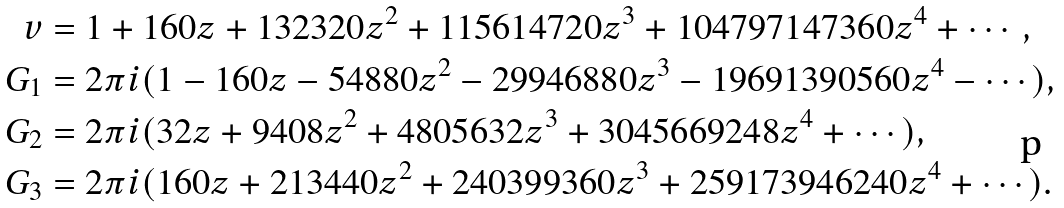Convert formula to latex. <formula><loc_0><loc_0><loc_500><loc_500>v & = 1 + 1 6 0 z + 1 3 2 3 2 0 z ^ { 2 } + 1 1 5 6 1 4 7 2 0 z ^ { 3 } + 1 0 4 7 9 7 1 4 7 3 6 0 z ^ { 4 } + \cdots , \\ G _ { 1 } & = 2 \pi i ( 1 - 1 6 0 z - 5 4 8 8 0 z ^ { 2 } - 2 9 9 4 6 8 8 0 z ^ { 3 } - 1 9 6 9 1 3 9 0 5 6 0 z ^ { 4 } - \cdots ) , \\ G _ { 2 } & = 2 \pi i ( 3 2 z + 9 4 0 8 z ^ { 2 } + 4 8 0 5 6 3 2 z ^ { 3 } + 3 0 4 5 6 6 9 2 4 8 z ^ { 4 } + \cdots ) , \\ G _ { 3 } & = 2 \pi i ( 1 6 0 z + 2 1 3 4 4 0 z ^ { 2 } + 2 4 0 3 9 9 3 6 0 z ^ { 3 } + 2 5 9 1 7 3 9 4 6 2 4 0 z ^ { 4 } + \cdots ) .</formula> 